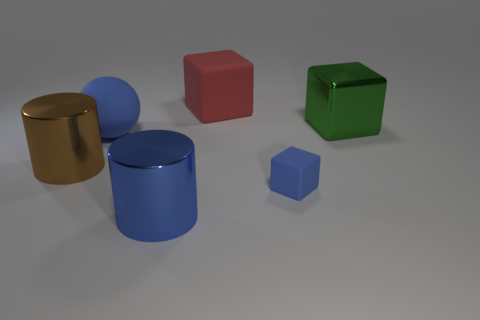Does the big green object have the same shape as the big blue metal thing?
Ensure brevity in your answer.  No. Is there anything else that has the same material as the red block?
Keep it short and to the point. Yes. What number of objects are both on the left side of the blue metal thing and right of the red matte block?
Your answer should be very brief. 0. There is a metal object behind the large matte object in front of the big metal cube; what color is it?
Your response must be concise. Green. Is the number of red matte blocks that are right of the big red matte thing the same as the number of small matte blocks?
Offer a very short reply. No. What number of blue blocks are in front of the tiny rubber cube to the right of the matte object behind the green cube?
Keep it short and to the point. 0. There is a large matte block left of the big green object; what is its color?
Your answer should be very brief. Red. What is the material of the large thing that is both in front of the blue sphere and behind the small blue matte cube?
Ensure brevity in your answer.  Metal. There is a big green shiny block that is behind the tiny blue matte thing; how many large shiny things are left of it?
Make the answer very short. 2. The tiny thing is what shape?
Your answer should be compact. Cube. 